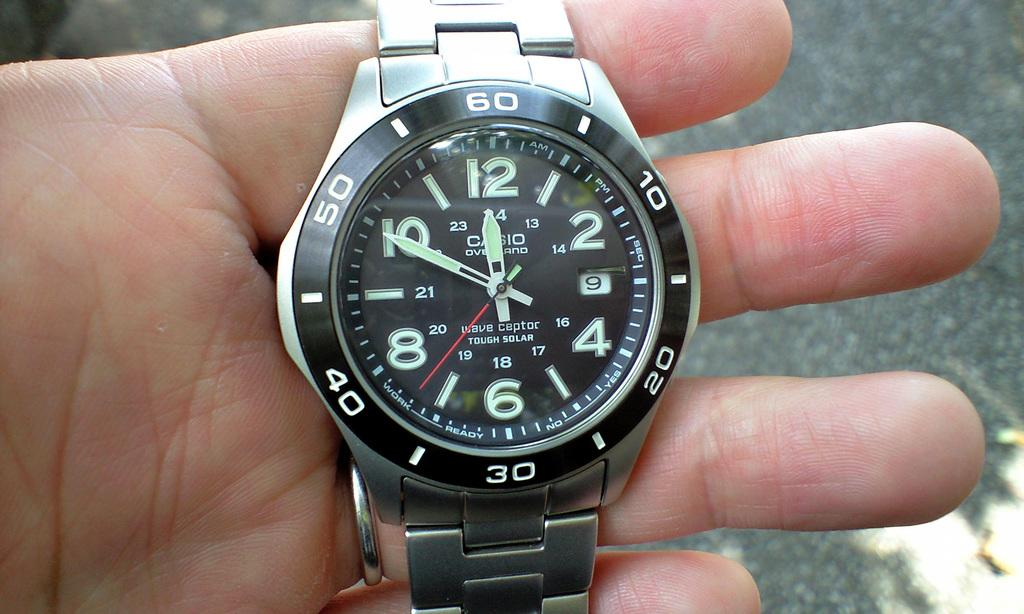Provide a one-sentence caption for the provided image. The wave ceptor watch has a solar feature and glows in the dark. 